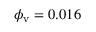<formula> <loc_0><loc_0><loc_500><loc_500>\phi _ { v } = 0 . 0 1 6</formula> 